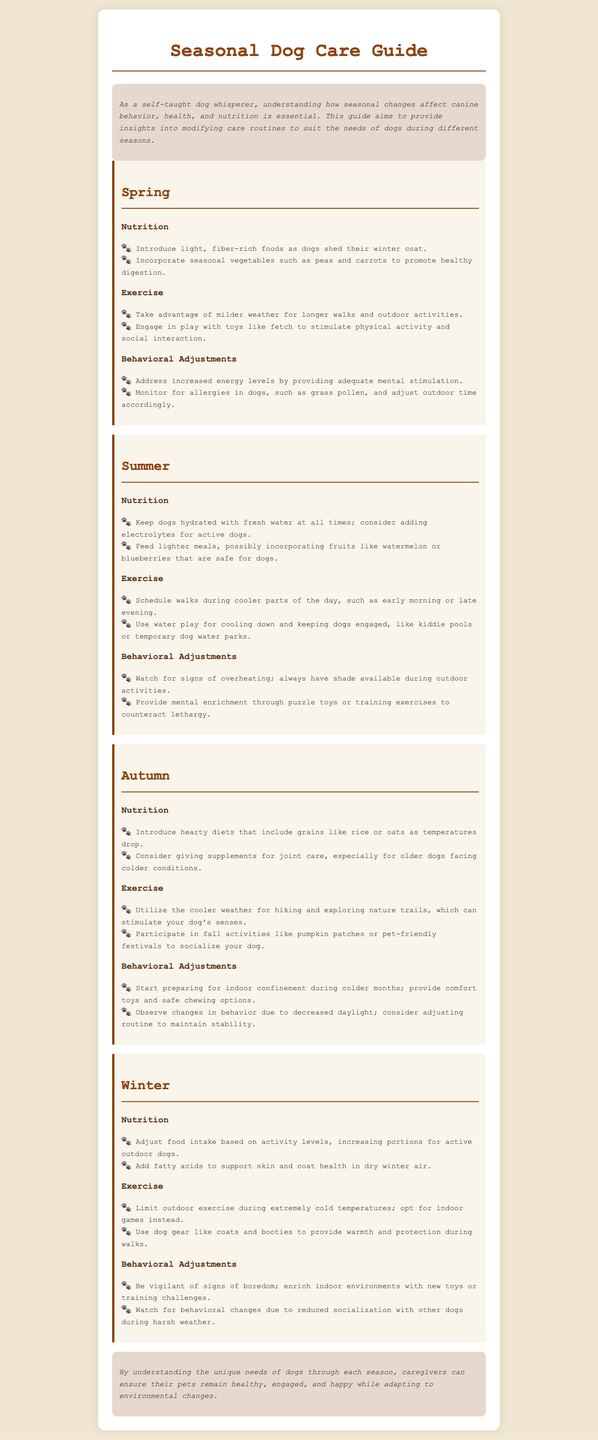What is the main purpose of the guide? The guide aims to provide insights into modifying care routines to suit the needs of dogs during different seasons.
Answer: Modifying care routines What should you introduce in a dog's diet during spring? During spring, it is recommended to introduce light, fiber-rich foods as dogs shed their winter coat.
Answer: Light, fiber-rich foods When is it suggested to walk dogs in the summer? It is suggested to schedule walks during cooler parts of the day, such as early morning or late evening.
Answer: Cooler parts of the day What activity is recommended for autumn to stimulate a dog's senses? In autumn, it is recommended to utilize the cooler weather for hiking and exploring nature trails.
Answer: Hiking and exploring nature trails What nutritional adjustment is recommended for winter? It is recommended to adjust food intake based on activity levels, increasing portions for active outdoor dogs.
Answer: Increase portions for active outdoor dogs Which season requires monitoring for signs of overheating? Signs of overheating must be monitored during the summer season.
Answer: Summer What kind of environmental enrichment should be provided in winter? In winter, it is suggested to enrich indoor environments with new toys or training challenges.
Answer: New toys or training challenges What should be monitored during spring related to allergies? During spring, allergies in dogs, such as grass pollen, should be monitored and outdoor time adjusted accordingly.
Answer: Grass pollen What are two types of activities suggested for dogs in autumn? In autumn, hiking and participating in pet-friendly festivals are suggested activities.
Answer: Hiking and pet-friendly festivals 